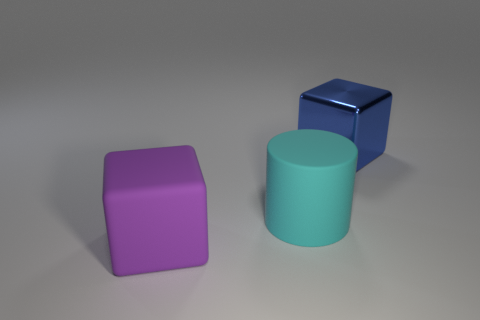How many large blocks are both behind the cyan thing and on the left side of the cyan rubber cylinder?
Offer a terse response. 0. What is the material of the big cyan cylinder?
Keep it short and to the point. Rubber. What number of things are small green cubes or cubes?
Your answer should be very brief. 2. There is a object in front of the large cyan thing; is it the same size as the object on the right side of the cylinder?
Give a very brief answer. Yes. How many other things are the same size as the cyan matte thing?
Offer a very short reply. 2. What number of things are either objects in front of the large metal cube or objects that are right of the large purple cube?
Make the answer very short. 3. Does the blue block have the same material as the large cube that is left of the big blue thing?
Your answer should be compact. No. What number of other objects are there of the same shape as the large purple thing?
Ensure brevity in your answer.  1. What is the big cylinder behind the cube that is in front of the big thing behind the matte cylinder made of?
Offer a terse response. Rubber. Is the number of big things that are right of the big blue block the same as the number of large red objects?
Provide a succinct answer. Yes. 